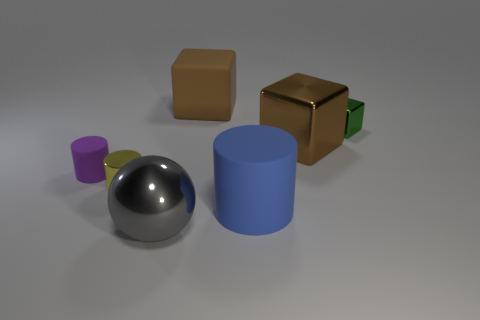Subtract all brown blocks. How many were subtracted if there are1brown blocks left? 1 Add 1 small purple cylinders. How many objects exist? 8 Subtract all balls. How many objects are left? 6 Subtract all large green metallic cylinders. Subtract all big balls. How many objects are left? 6 Add 4 big gray shiny balls. How many big gray shiny balls are left? 5 Add 7 brown cylinders. How many brown cylinders exist? 7 Subtract 2 brown cubes. How many objects are left? 5 